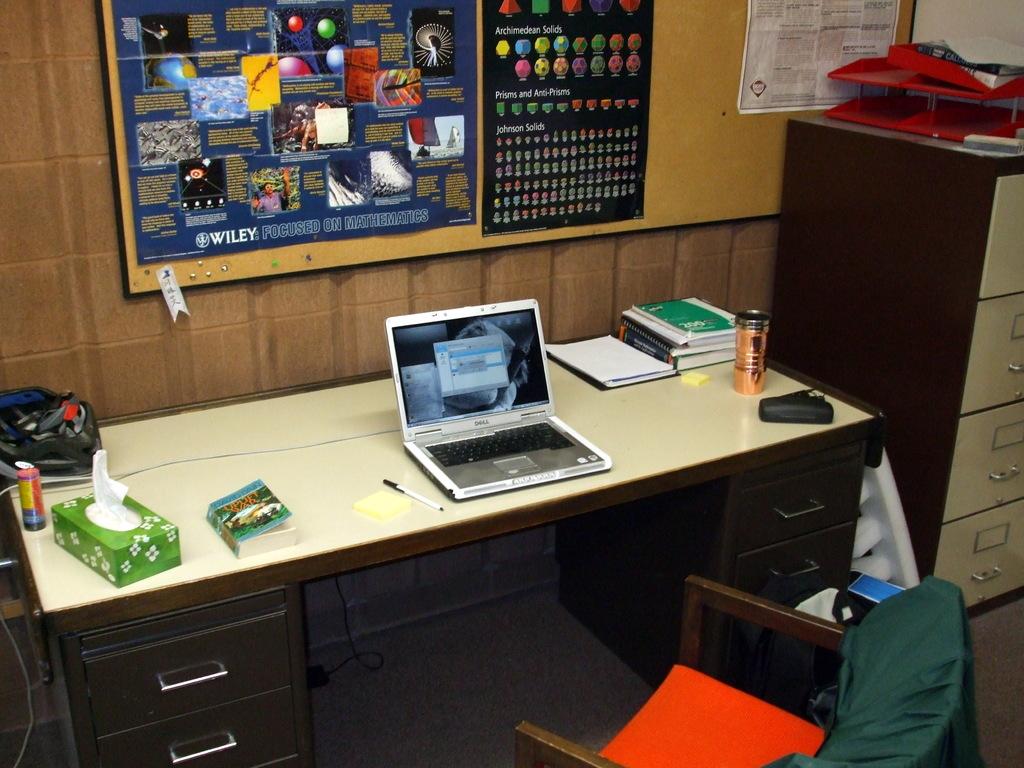According to the poster, what should one be focused on?
Offer a terse response. Mathematics. What are the capital letters in white on the poster?
Provide a short and direct response. Wiley. 